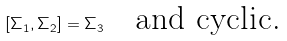<formula> <loc_0><loc_0><loc_500><loc_500>[ \Sigma _ { 1 } , \Sigma _ { 2 } ] = \Sigma _ { 3 } \quad \text {and cyclic.}</formula> 